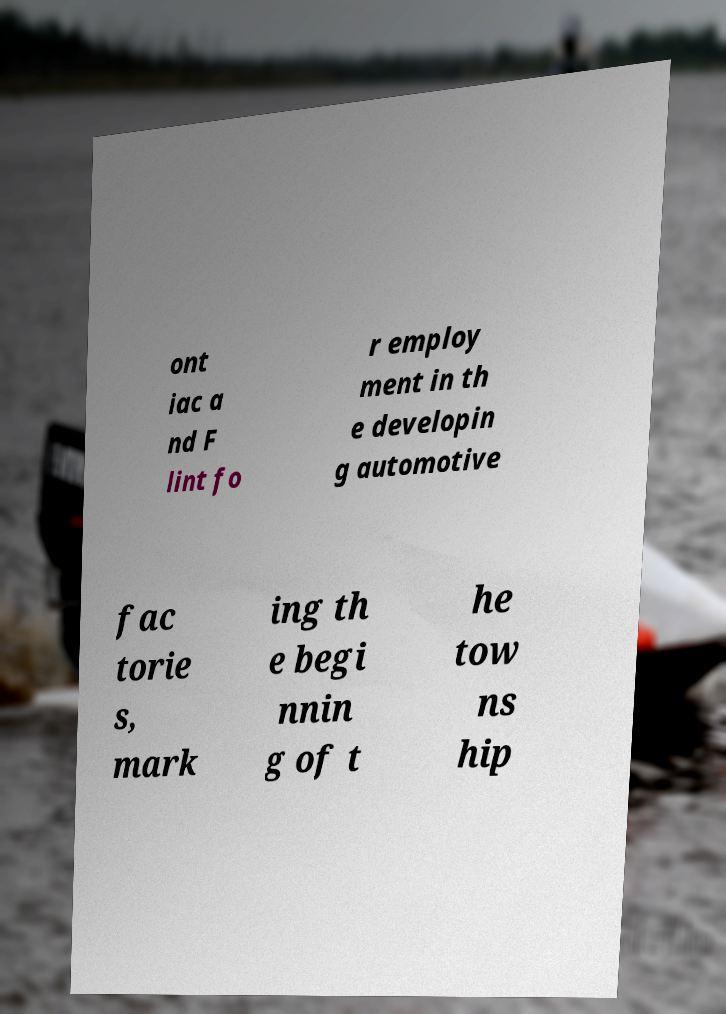Please read and relay the text visible in this image. What does it say? ont iac a nd F lint fo r employ ment in th e developin g automotive fac torie s, mark ing th e begi nnin g of t he tow ns hip 